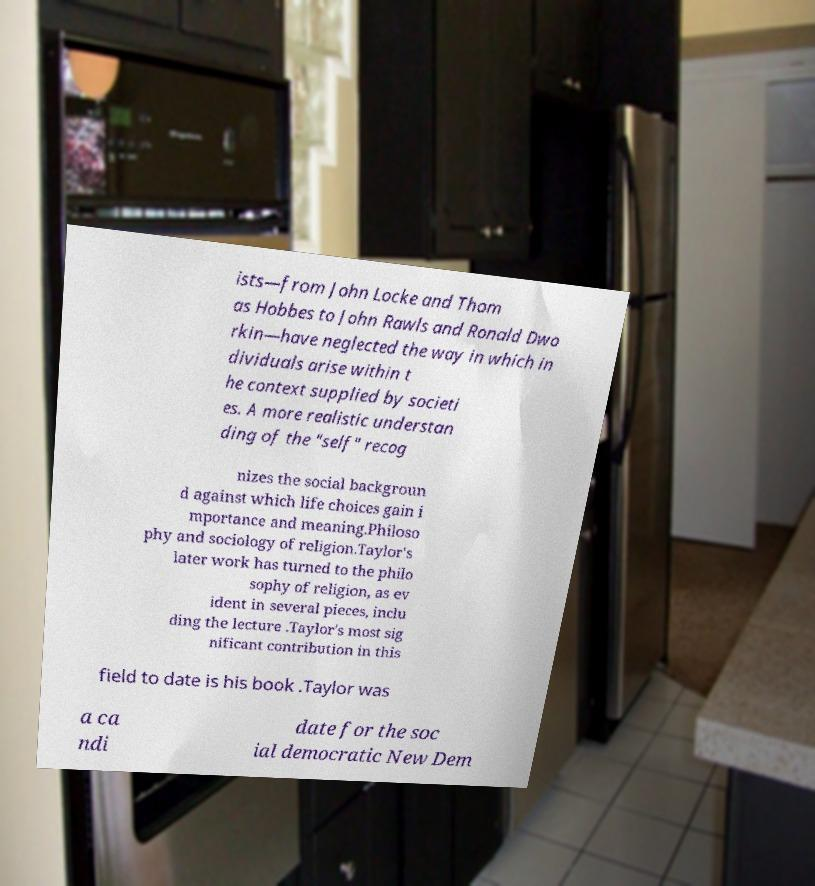Please read and relay the text visible in this image. What does it say? ists—from John Locke and Thom as Hobbes to John Rawls and Ronald Dwo rkin—have neglected the way in which in dividuals arise within t he context supplied by societi es. A more realistic understan ding of the "self" recog nizes the social backgroun d against which life choices gain i mportance and meaning.Philoso phy and sociology of religion.Taylor's later work has turned to the philo sophy of religion, as ev ident in several pieces, inclu ding the lecture .Taylor's most sig nificant contribution in this field to date is his book .Taylor was a ca ndi date for the soc ial democratic New Dem 